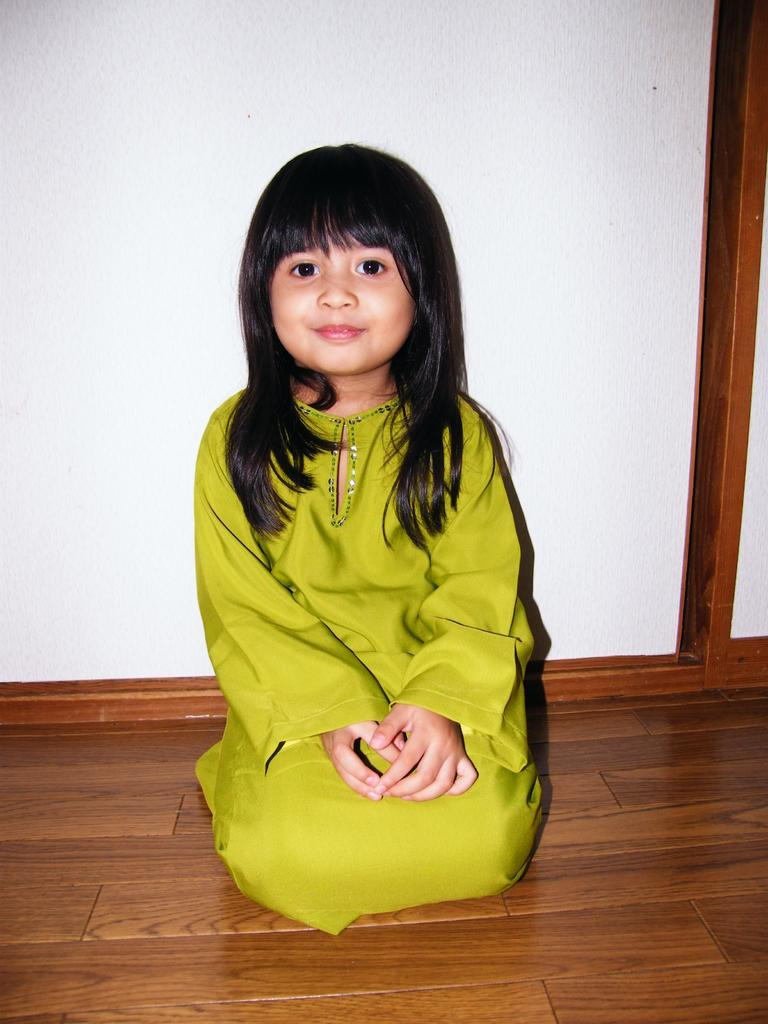Who is the main subject in the image? There is a girl in the image. What is the girl's location in the image? The girl is on the wooden floor. What can be seen in the background of the image? There is a wall in the background of the image. What type of snail can be seen crawling on the wall in the image? There is no snail present in the image; the background only features a wall. What is the girl using to tie up the pot in the image? There is no pot or string present in the image. 